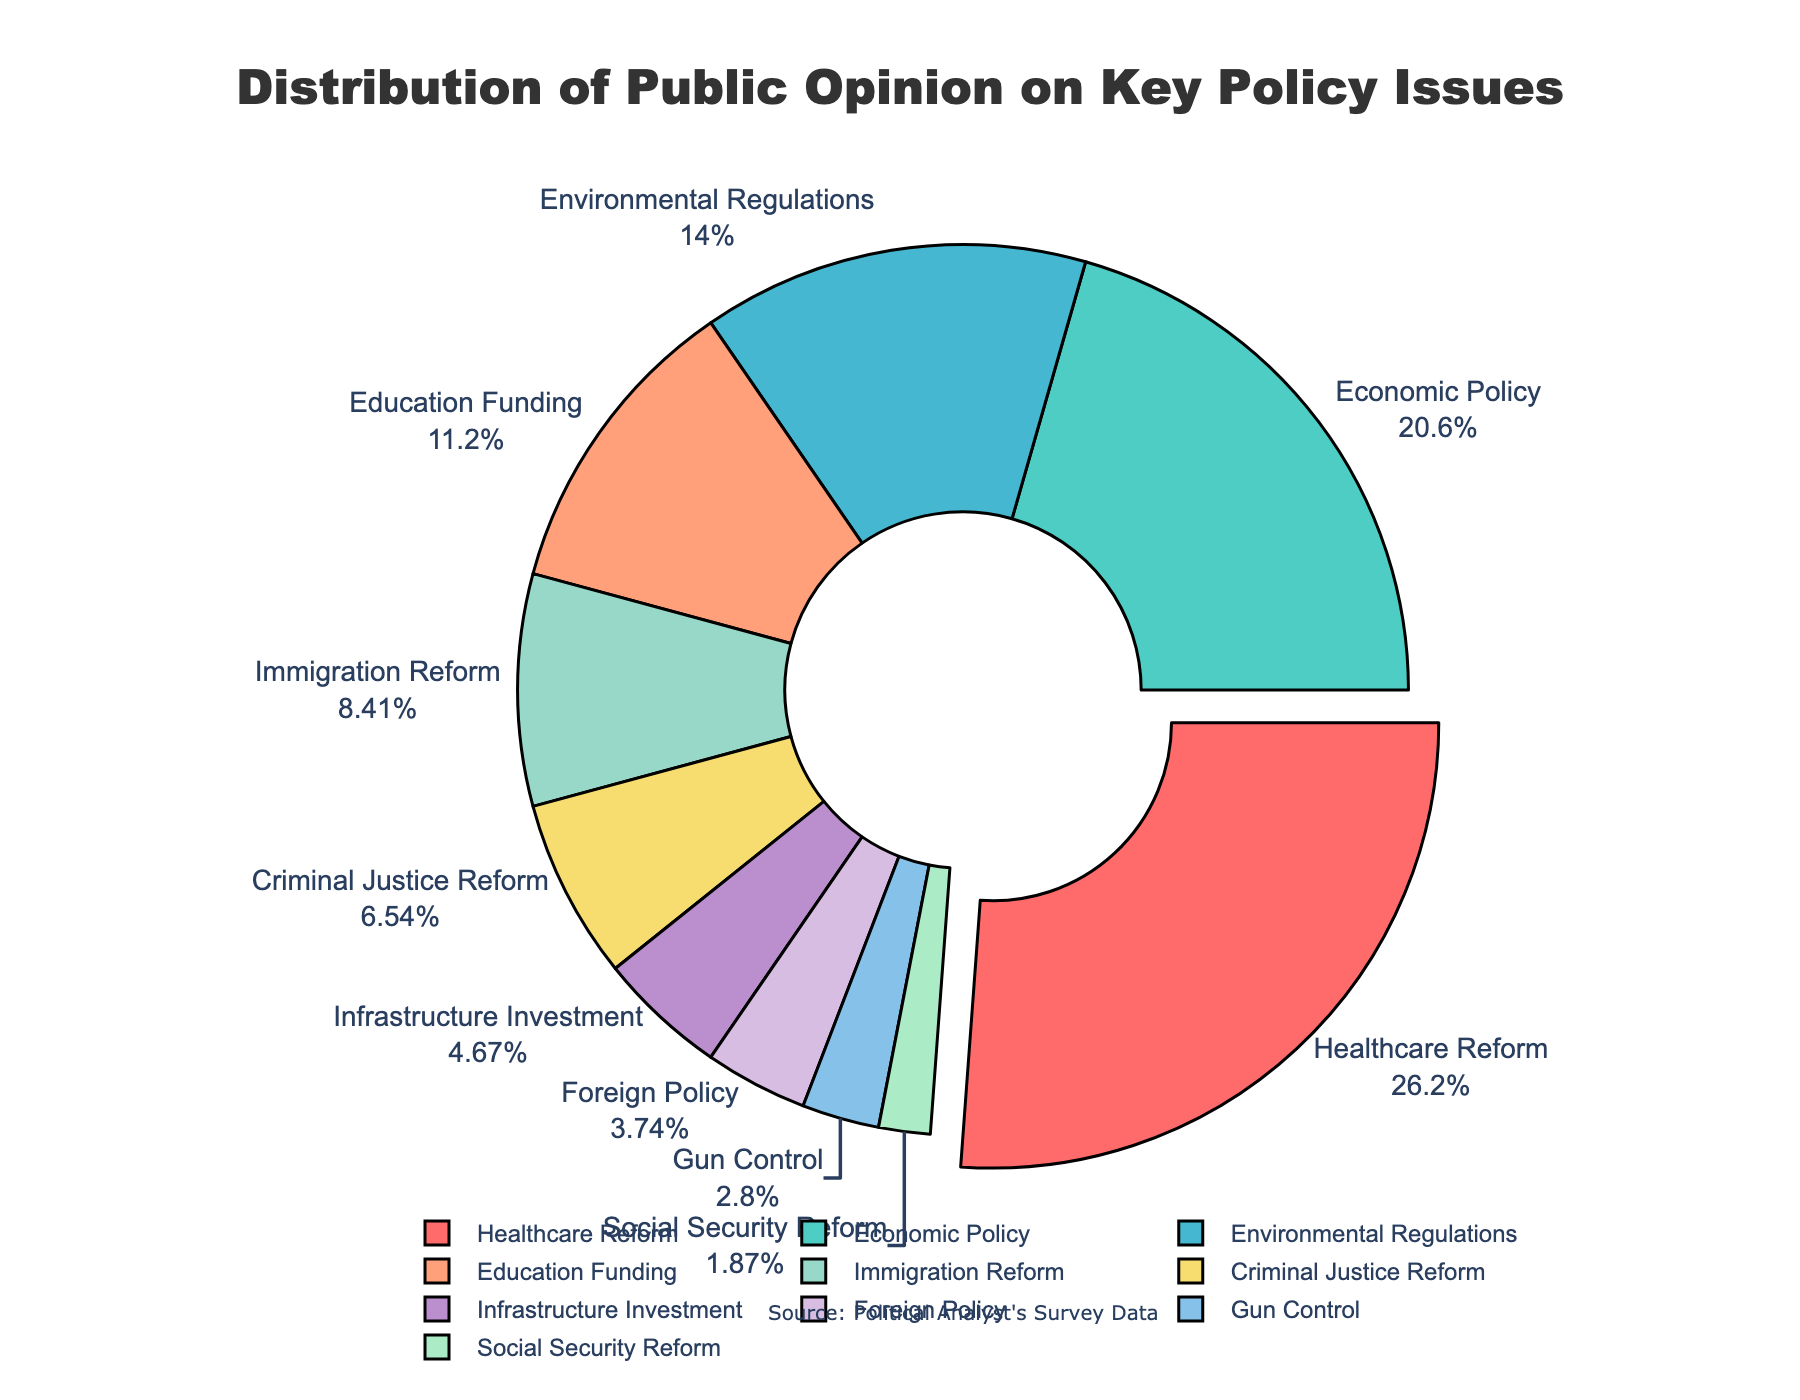What is the most popular policy issue according to the chart? The chart highlights each segment of public opinion with a slice, and the sizes denote the percentage. The slice labeled "Healthcare Reform" is the largest with a 28% share, indicating it is the most popular issue.
Answer: Healthcare Reform Which policy issues have a combined percentage equal to or greater than that of Economic Policy? The chart shows Economic Policy with 22%. Combining Education Funding (12%) and Environmental Regulations (15%), which equals 27%, meets the requirement as their total is greater than 22%.
Answer: Education Funding and Environmental Regulations What is the percentage difference between the least popular and the most popular policy issues? "Social Security Reform" at 2% is the least popular, and "Healthcare Reform" at 28% is the most popular. The difference is 28% - 2%, which is 26%.
Answer: 26% How much more popular is Immigration Reform compared to Gun Control? Immigration Reform has 9%, and Gun Control has 3%. The difference is 9% - 3%, which is 6%.
Answer: 6% Which issue is represented by the slice pulled out slightly from the pie chart? In the chart, the slice for the most popular issue, "Healthcare Reform," is pulled out slightly for emphasis.
Answer: Healthcare Reform What is the combined percentage of Foreign Policy and Gun Control? Foreign Policy represents 4%, and Gun Control represents 3%. Adding them together, we get 4% + 3% = 7%.
Answer: 7% Are there more slices colored in shades of blue or shades of green in the chart? The chart uses colors, with shades of blue representing Economic Policy and Education Funding, and shades of green representing Immigration Reform and Gun Control. There are two categories for each color.
Answer: Equal (2 for blue, 2 for green) Which policy issues have less than 10% support? According to the chart, Education Funding (12%), Immigration Reform (9%), Criminal Justice Reform (7%), Infrastructure Investment (5%), Foreign Policy (4%), Gun Control (3%), and Social Security Reform (2%) have less than 10% support.
Answer: Criminal Justice Reform, Infrastructure Investment, Foreign Policy, Gun Control, Social Security Reform What is the percentage for issues related to governance and law combined (Economic Policy, Criminal Justice Reform, Foreign Policy)? We need to add percentages for Economic Policy (22%), Criminal Justice Reform (7%), and Foreign Policy (4%). The combined percentage is 22% + 7% + 4% = 33%.
Answer: 33% 